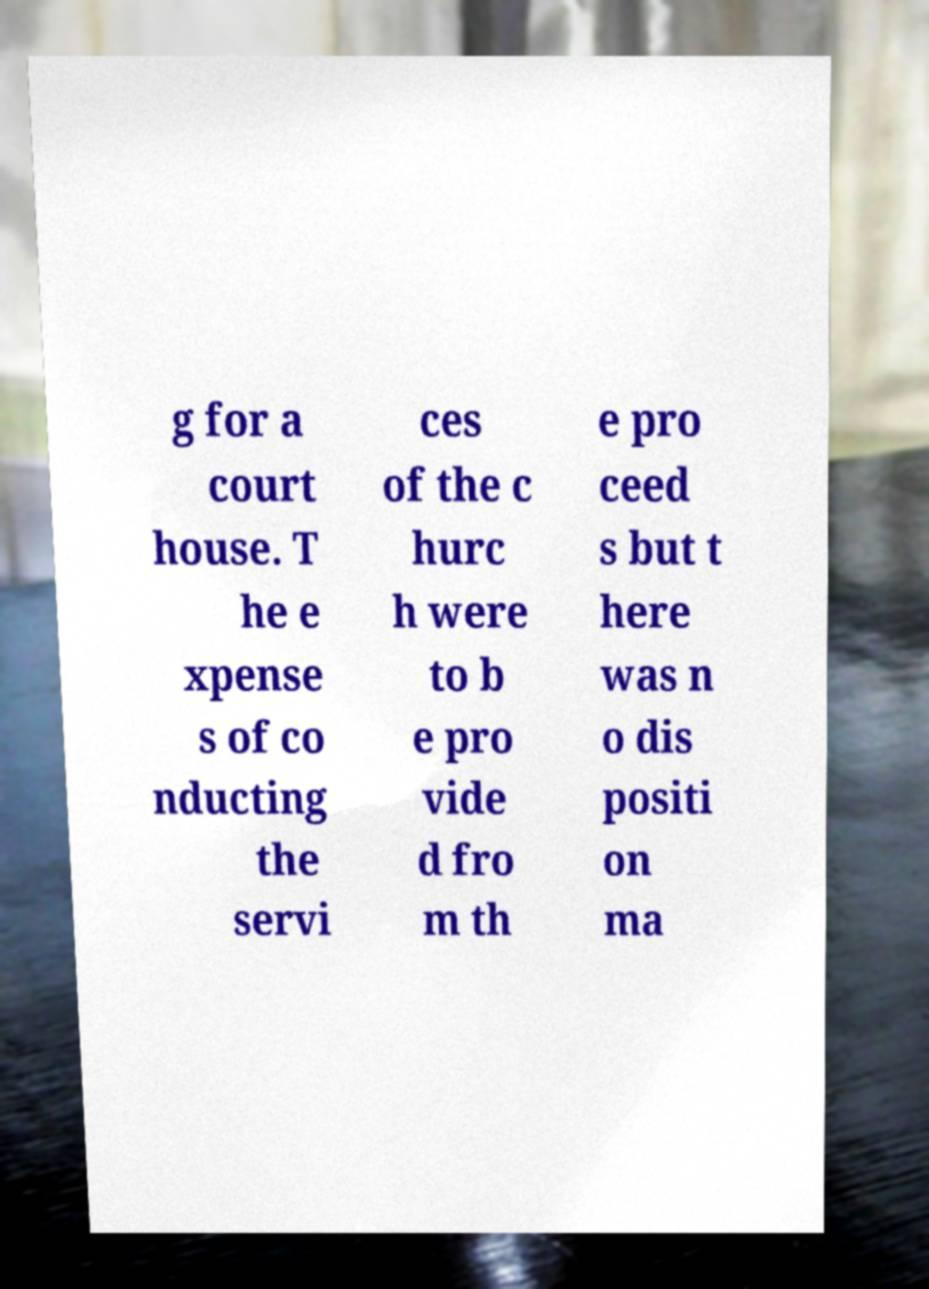Please read and relay the text visible in this image. What does it say? g for a court house. T he e xpense s of co nducting the servi ces of the c hurc h were to b e pro vide d fro m th e pro ceed s but t here was n o dis positi on ma 